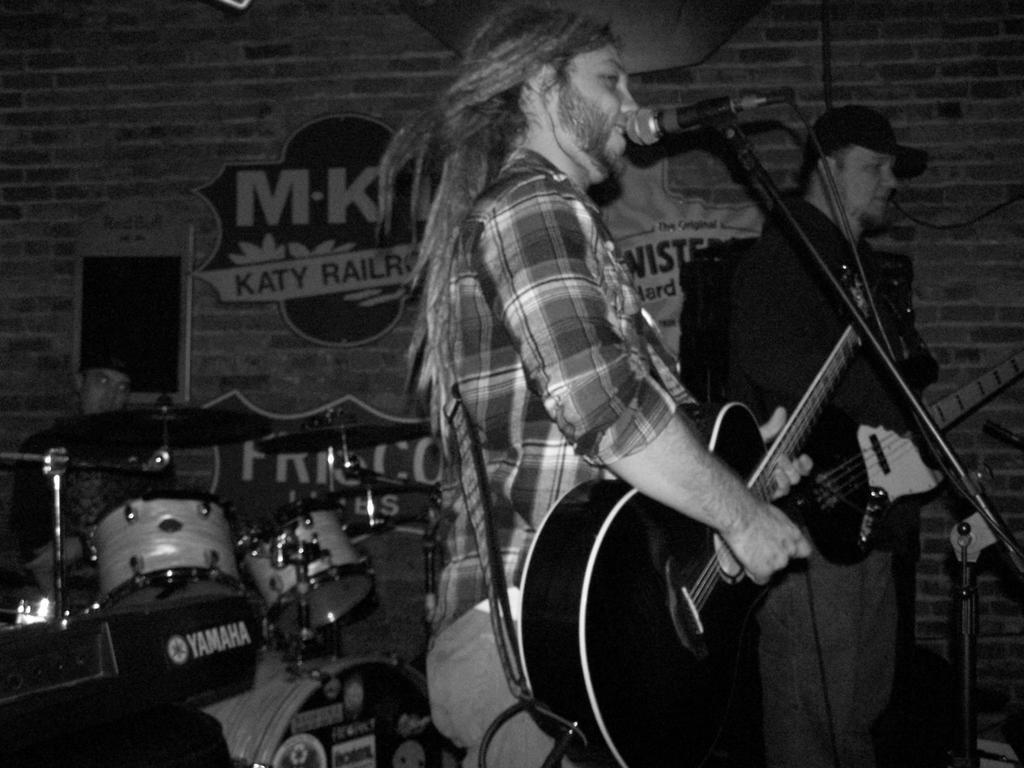How would you summarize this image in a sentence or two? In the image we can see there are people who are standing and holding guitar in their hand and there is a drum set which is played by a man and the image is in black and white colour. 